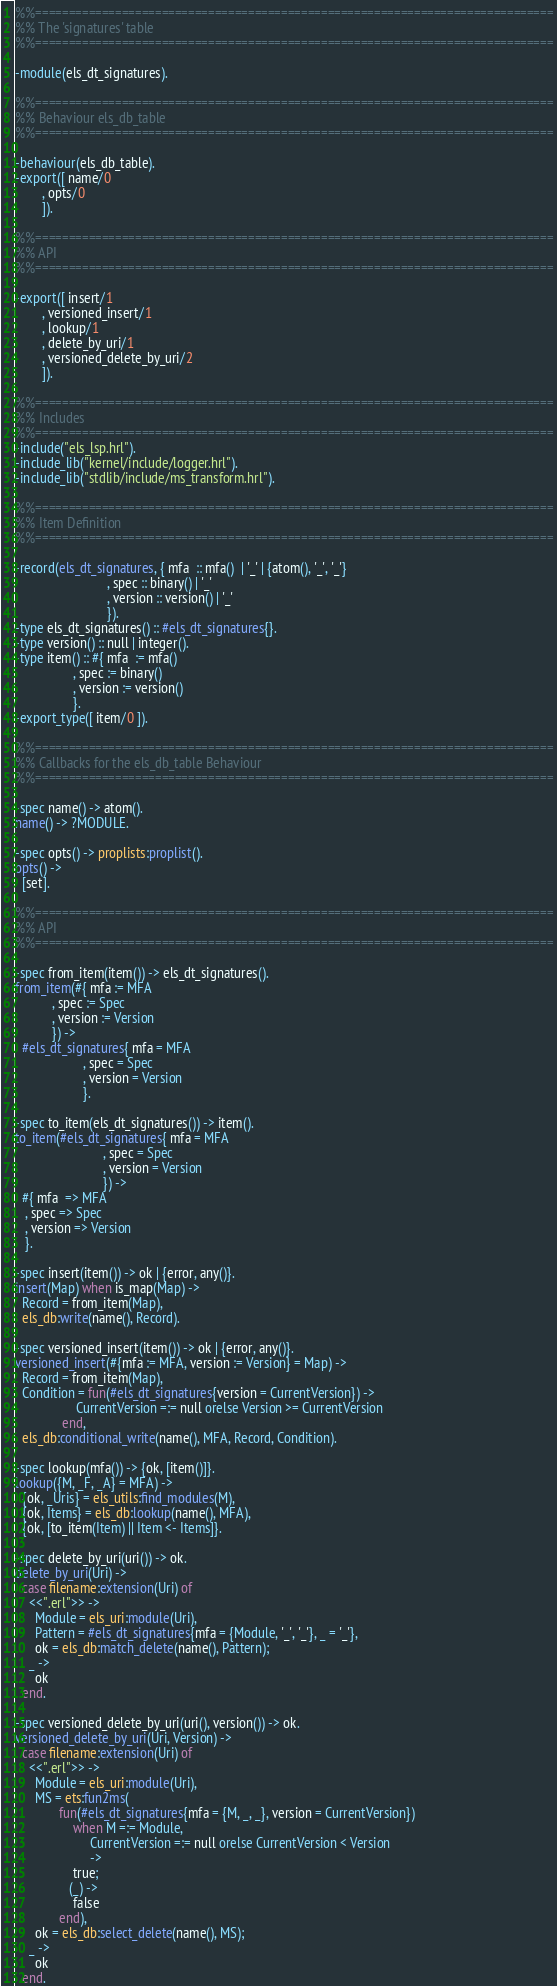<code> <loc_0><loc_0><loc_500><loc_500><_Erlang_>%%==============================================================================
%% The 'signatures' table
%%==============================================================================

-module(els_dt_signatures).

%%==============================================================================
%% Behaviour els_db_table
%%==============================================================================

-behaviour(els_db_table).
-export([ name/0
        , opts/0
        ]).

%%==============================================================================
%% API
%%==============================================================================

-export([ insert/1
        , versioned_insert/1
        , lookup/1
        , delete_by_uri/1
        , versioned_delete_by_uri/2
        ]).

%%==============================================================================
%% Includes
%%==============================================================================
-include("els_lsp.hrl").
-include_lib("kernel/include/logger.hrl").
-include_lib("stdlib/include/ms_transform.hrl").

%%==============================================================================
%% Item Definition
%%==============================================================================

-record(els_dt_signatures, { mfa  :: mfa()  | '_' | {atom(), '_', '_'}
                           , spec :: binary() | '_'
                           , version :: version() | '_'
                           }).
-type els_dt_signatures() :: #els_dt_signatures{}.
-type version() :: null | integer().
-type item() :: #{ mfa  := mfa()
                 , spec := binary()
                 , version := version()
                 }.
-export_type([ item/0 ]).

%%==============================================================================
%% Callbacks for the els_db_table Behaviour
%%==============================================================================

-spec name() -> atom().
name() -> ?MODULE.

-spec opts() -> proplists:proplist().
opts() ->
  [set].

%%==============================================================================
%% API
%%==============================================================================

-spec from_item(item()) -> els_dt_signatures().
from_item(#{ mfa := MFA
           , spec := Spec
           , version := Version
           }) ->
  #els_dt_signatures{ mfa = MFA
                    , spec = Spec
                    , version = Version
                    }.

-spec to_item(els_dt_signatures()) -> item().
to_item(#els_dt_signatures{ mfa = MFA
                          , spec = Spec
                          , version = Version
                          }) ->
  #{ mfa  => MFA
   , spec => Spec
   , version => Version
   }.

-spec insert(item()) -> ok | {error, any()}.
insert(Map) when is_map(Map) ->
  Record = from_item(Map),
  els_db:write(name(), Record).

-spec versioned_insert(item()) -> ok | {error, any()}.
versioned_insert(#{mfa := MFA, version := Version} = Map) ->
  Record = from_item(Map),
  Condition = fun(#els_dt_signatures{version = CurrentVersion}) ->
                  CurrentVersion =:= null orelse Version >= CurrentVersion
              end,
  els_db:conditional_write(name(), MFA, Record, Condition).

-spec lookup(mfa()) -> {ok, [item()]}.
lookup({M, _F, _A} = MFA) ->
  {ok, _Uris} = els_utils:find_modules(M),
  {ok, Items} = els_db:lookup(name(), MFA),
  {ok, [to_item(Item) || Item <- Items]}.

-spec delete_by_uri(uri()) -> ok.
delete_by_uri(Uri) ->
  case filename:extension(Uri) of
    <<".erl">> ->
      Module = els_uri:module(Uri),
      Pattern = #els_dt_signatures{mfa = {Module, '_', '_'}, _ = '_'},
      ok = els_db:match_delete(name(), Pattern);
    _ ->
      ok
  end.

-spec versioned_delete_by_uri(uri(), version()) -> ok.
versioned_delete_by_uri(Uri, Version) ->
  case filename:extension(Uri) of
    <<".erl">> ->
      Module = els_uri:module(Uri),
      MS = ets:fun2ms(
             fun(#els_dt_signatures{mfa = {M, _, _}, version = CurrentVersion})
                 when M =:= Module,
                      CurrentVersion =:= null orelse CurrentVersion < Version
                      ->
                 true;
                (_) ->
                 false
             end),
      ok = els_db:select_delete(name(), MS);
    _ ->
      ok
  end.
</code> 